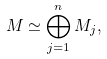Convert formula to latex. <formula><loc_0><loc_0><loc_500><loc_500>M \simeq \bigoplus _ { j = 1 } ^ { n } M _ { j } ,</formula> 